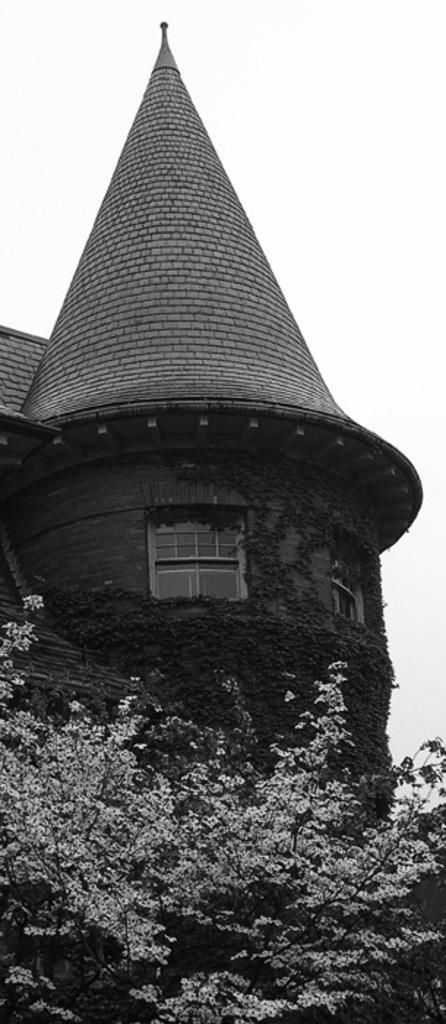In one or two sentences, can you explain what this image depicts? This is a black and white pic. At the bottom we can see branches of a tree. In the background there is a building, roofs, windows, plants and the sky. 